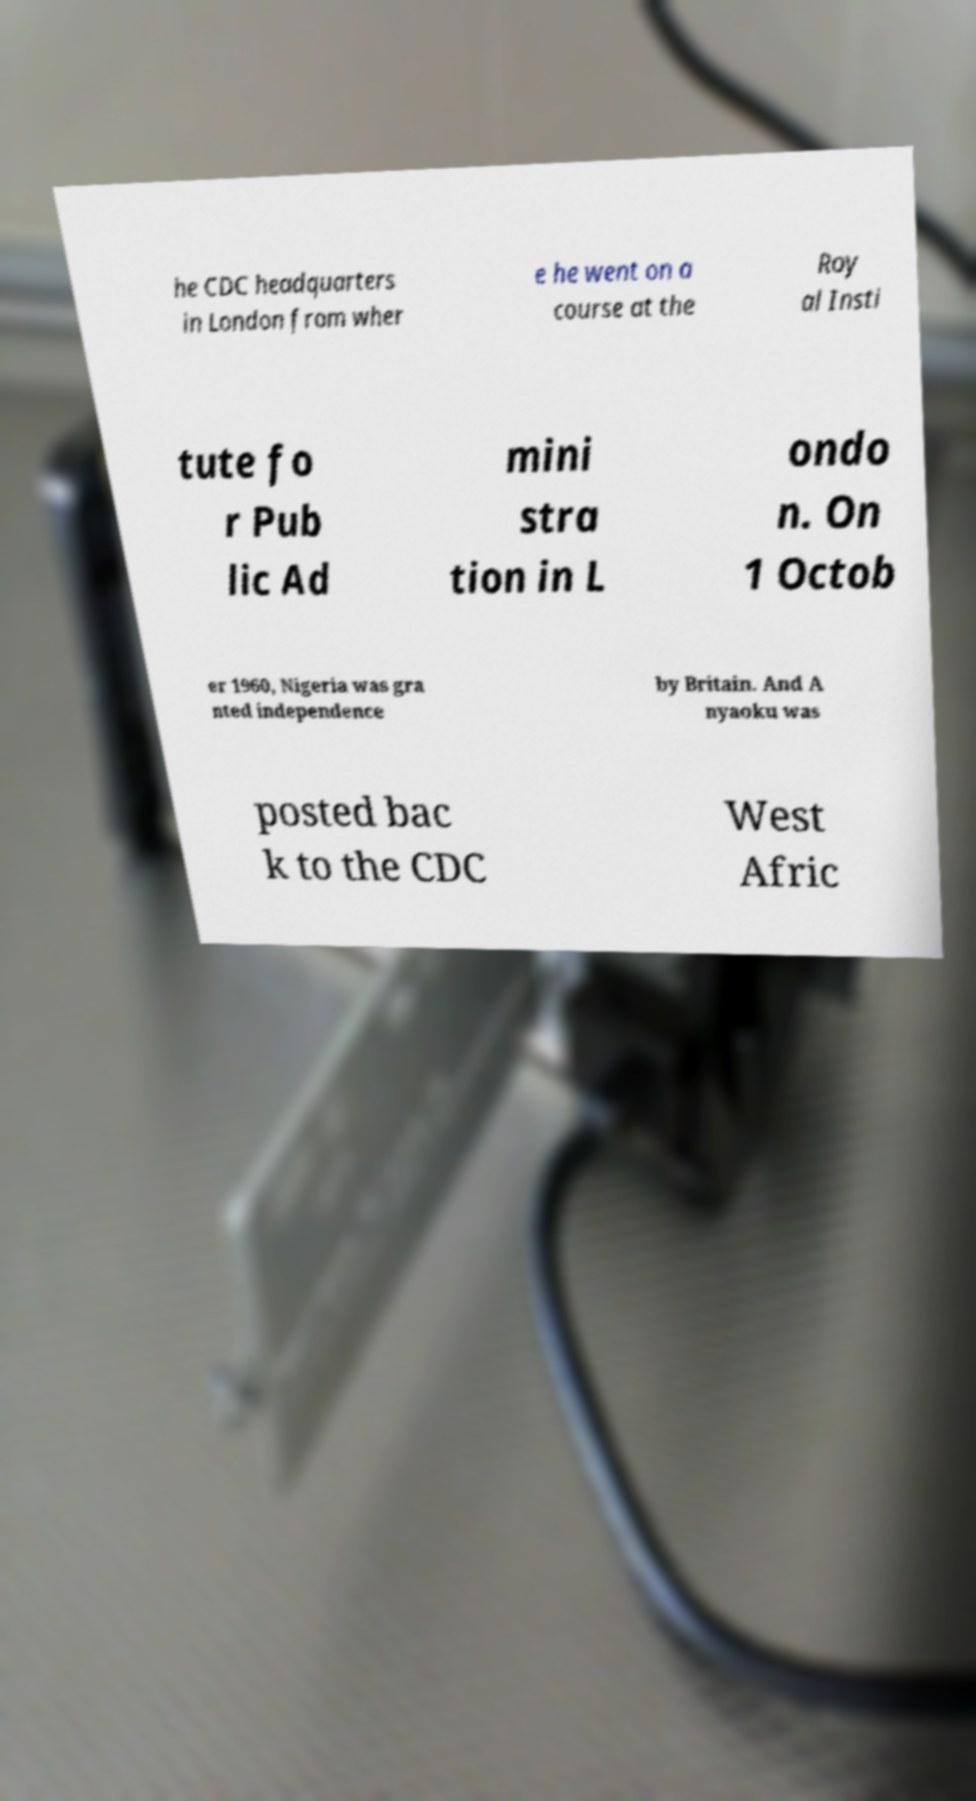For documentation purposes, I need the text within this image transcribed. Could you provide that? he CDC headquarters in London from wher e he went on a course at the Roy al Insti tute fo r Pub lic Ad mini stra tion in L ondo n. On 1 Octob er 1960, Nigeria was gra nted independence by Britain. And A nyaoku was posted bac k to the CDC West Afric 